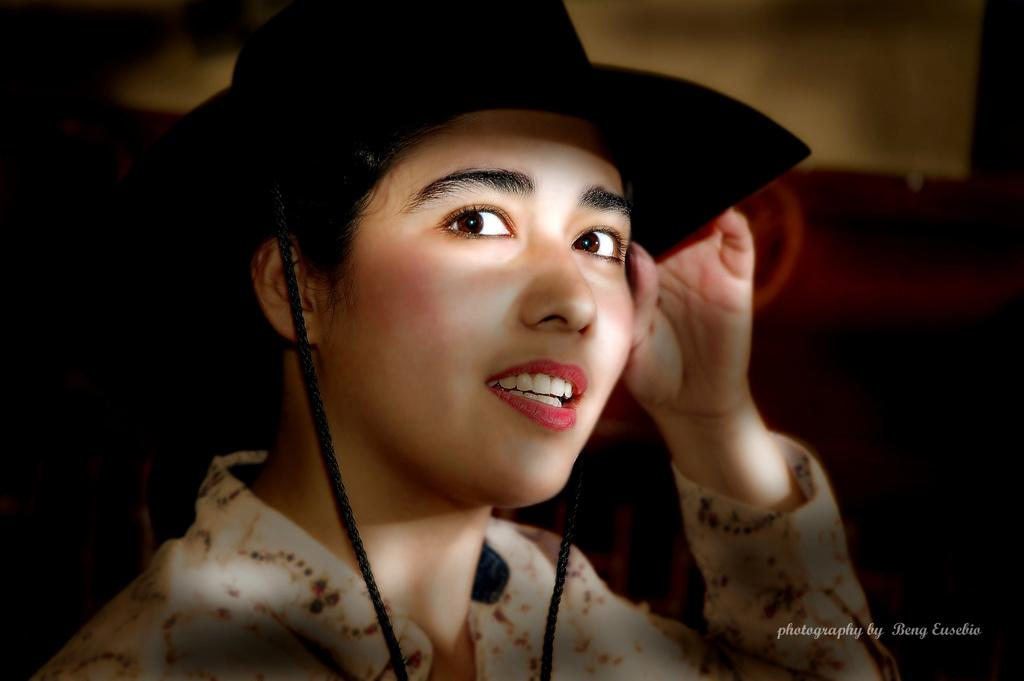Who is present in the image? There is a woman in the image. What is the woman wearing on her head? The woman is wearing a hat. Is there any text visible in the image? Yes, there is text in the bottom right corner of the image. What type of wire can be seen connecting the tomatoes in the image? There are no tomatoes or wires present in the image; it features a woman wearing a hat and text in the bottom right corner. 